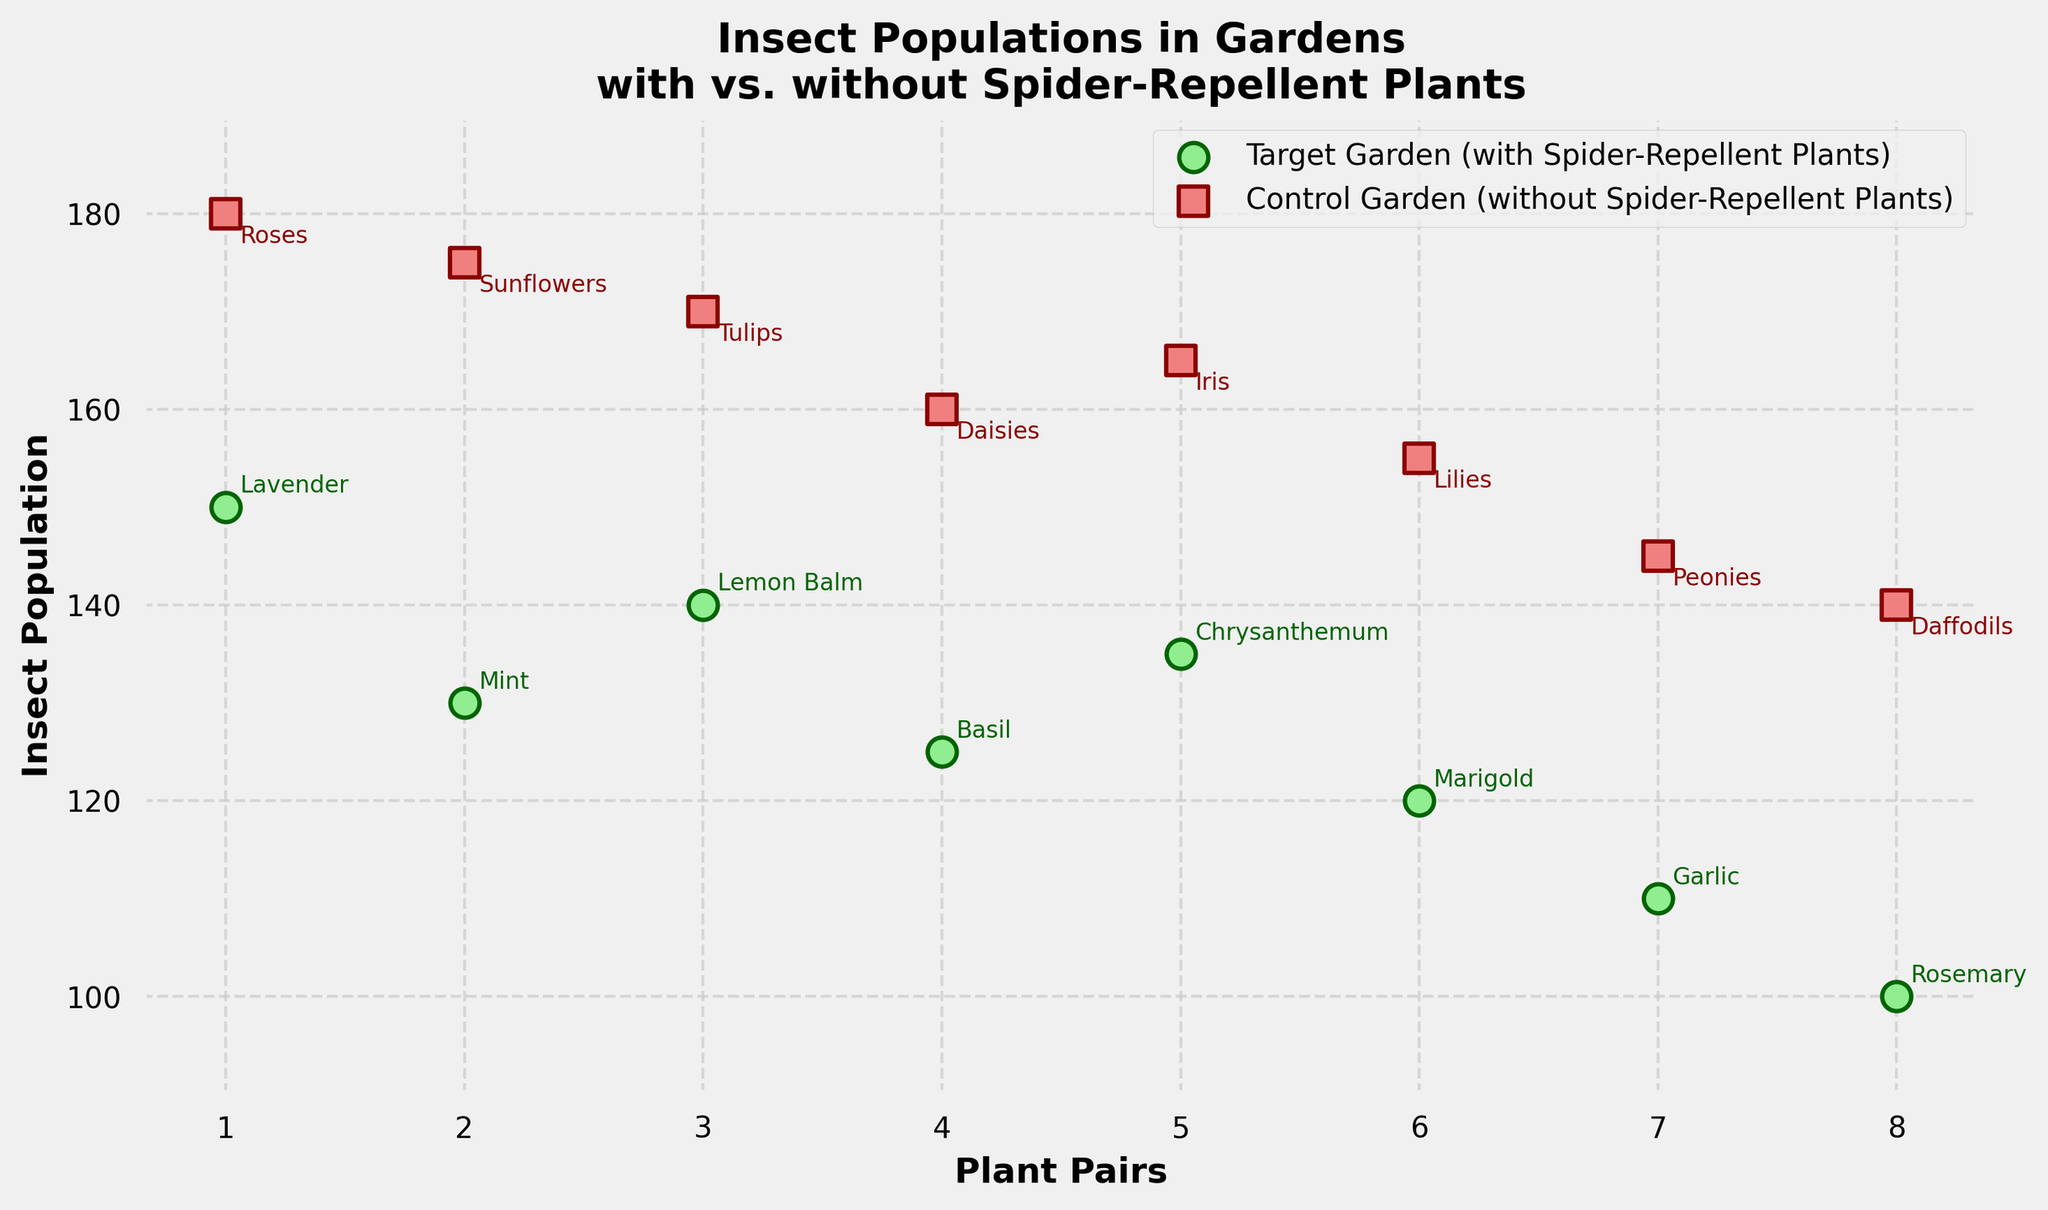What is the title of the scatter plot? The title of the scatter plot is located at the top center of the figure. It reads, "Insect Populations in Gardens\nwith vs. without Spider-Repellent Plants".
Answer: Insect Populations in Gardens\nwith vs. without Spider-Repellent Plants How many insect population data points are represented for the target garden? The target garden data points are represented by light green circles. By counting these circles, we see there are 8 data points.
Answer: 8 Which plant pair has the highest insect population in the control garden? By looking at the red squares, the highest red square is at 180. Annotated near this square is "Roses", which is paired with "Lavender".
Answer: Roses What is the average insect population in gardens with spider-repellent plants? Sum the insect populations from the target garden (150, 130, 140, 125, 135, 120, 110, 100) which equals 1010. There are 8 data points, so average = 1010 / 8 = 126.25.
Answer: 126.25 Which garden has a lower overall insect population, the target garden or the control garden? Compare the average insect population of the target garden (126.25) and the control garden (153.75). The target garden has a lower average insect population.
Answer: Target garden How much lower is the insect population in the garden with Chrysanthemum compared to its control garden counterpart? The insect population for Chrysanthemum is 135, and for its control garden counterpart (Iris) it's 165. The difference is 165 - 135 = 30.
Answer: 30 Which plant pairs show no overlap in insect populations between the gardens? Identify the pairs where green circles do not align vertically with red squares. Pairs: Lavender-Roses, Mint-Sunflowers, Rosemary-Daffodils.
Answer: Lavender-Roses, Mint-Sunflowers, Rosemary-Daffodils What is the population range in the target garden? The range is calculated by subtracting the smallest value (100 for Rosemary) from the largest value (150 for Lavender). Range = 150 - 100 = 50.
Answer: 50 Are there any insect populations that are the same between the target and control gardens for any pair? Look for overlapping green circles and red squares. There are no overlapping points indicating same populations.
Answer: No What is the general trend in insect population between gardens with and without spider-repellent plants? Generally, the insect populations in gardens with spider-repellent plants (green circles) are lower than those in gardens without them (red squares).
Answer: Lower in target gardens 